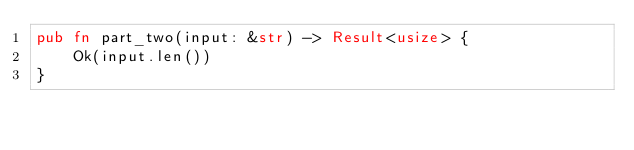<code> <loc_0><loc_0><loc_500><loc_500><_Rust_>pub fn part_two(input: &str) -> Result<usize> {
    Ok(input.len())
}
</code> 